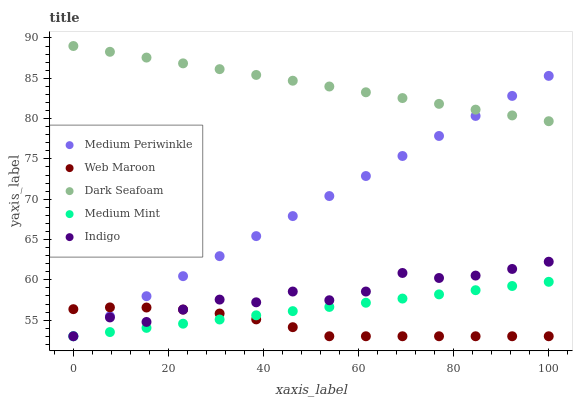Does Web Maroon have the minimum area under the curve?
Answer yes or no. Yes. Does Dark Seafoam have the maximum area under the curve?
Answer yes or no. Yes. Does Dark Seafoam have the minimum area under the curve?
Answer yes or no. No. Does Web Maroon have the maximum area under the curve?
Answer yes or no. No. Is Medium Periwinkle the smoothest?
Answer yes or no. Yes. Is Indigo the roughest?
Answer yes or no. Yes. Is Web Maroon the smoothest?
Answer yes or no. No. Is Web Maroon the roughest?
Answer yes or no. No. Does Medium Mint have the lowest value?
Answer yes or no. Yes. Does Dark Seafoam have the lowest value?
Answer yes or no. No. Does Dark Seafoam have the highest value?
Answer yes or no. Yes. Does Web Maroon have the highest value?
Answer yes or no. No. Is Medium Mint less than Dark Seafoam?
Answer yes or no. Yes. Is Dark Seafoam greater than Web Maroon?
Answer yes or no. Yes. Does Medium Mint intersect Medium Periwinkle?
Answer yes or no. Yes. Is Medium Mint less than Medium Periwinkle?
Answer yes or no. No. Is Medium Mint greater than Medium Periwinkle?
Answer yes or no. No. Does Medium Mint intersect Dark Seafoam?
Answer yes or no. No. 